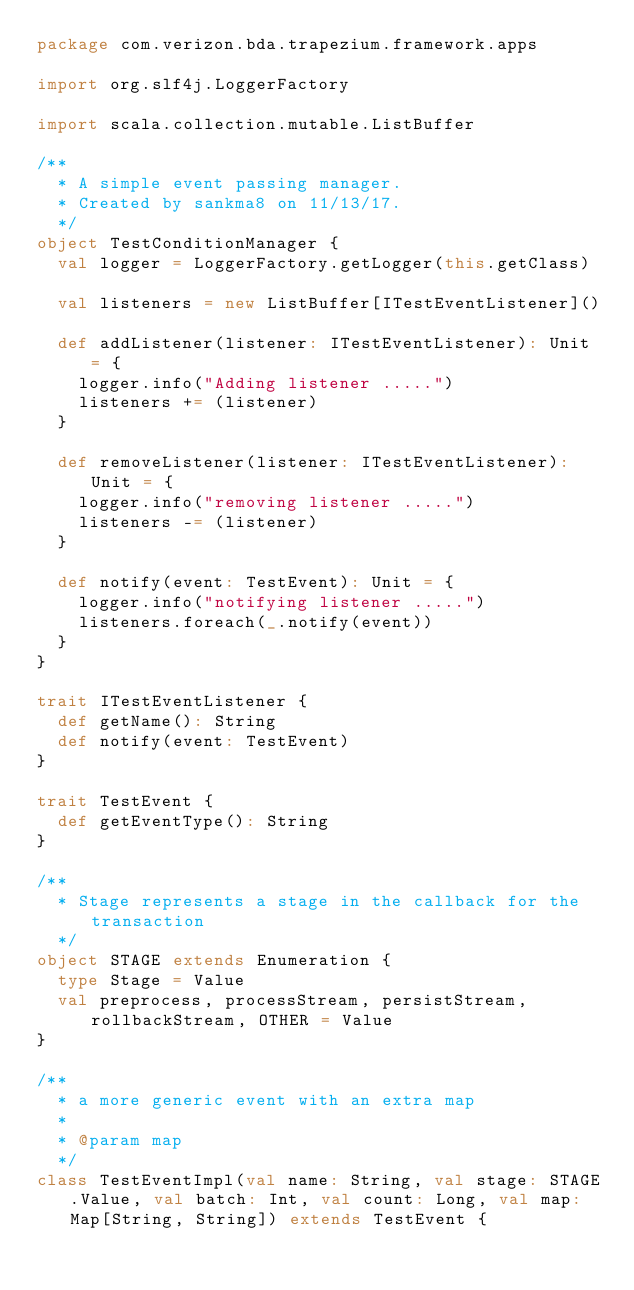<code> <loc_0><loc_0><loc_500><loc_500><_Scala_>package com.verizon.bda.trapezium.framework.apps

import org.slf4j.LoggerFactory

import scala.collection.mutable.ListBuffer

/**
  * A simple event passing manager.
  * Created by sankma8 on 11/13/17.
  */
object TestConditionManager {
  val logger = LoggerFactory.getLogger(this.getClass)

  val listeners = new ListBuffer[ITestEventListener]()

  def addListener(listener: ITestEventListener): Unit = {
    logger.info("Adding listener .....")
    listeners += (listener)
  }

  def removeListener(listener: ITestEventListener): Unit = {
    logger.info("removing listener .....")
    listeners -= (listener)
  }

  def notify(event: TestEvent): Unit = {
    logger.info("notifying listener .....")
    listeners.foreach(_.notify(event))
  }
}

trait ITestEventListener {
  def getName(): String
  def notify(event: TestEvent)
}

trait TestEvent {
  def getEventType(): String
}

/**
  * Stage represents a stage in the callback for the transaction
  */
object STAGE extends Enumeration {
  type Stage = Value
  val preprocess, processStream, persistStream, rollbackStream, OTHER = Value
}

/**
  * a more generic event with an extra map
  *
  * @param map
  */
class TestEventImpl(val name: String, val stage: STAGE.Value, val batch: Int, val count: Long, val map: Map[String, String]) extends TestEvent {

</code> 